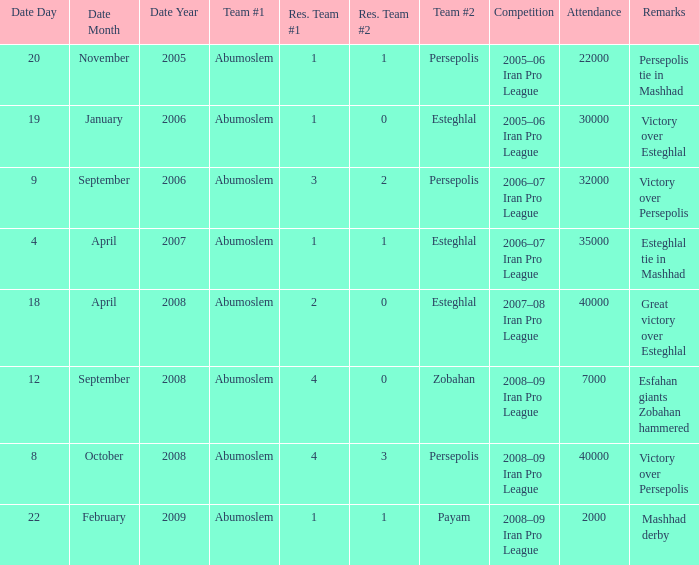What was the largest attendance? 40000.0. 